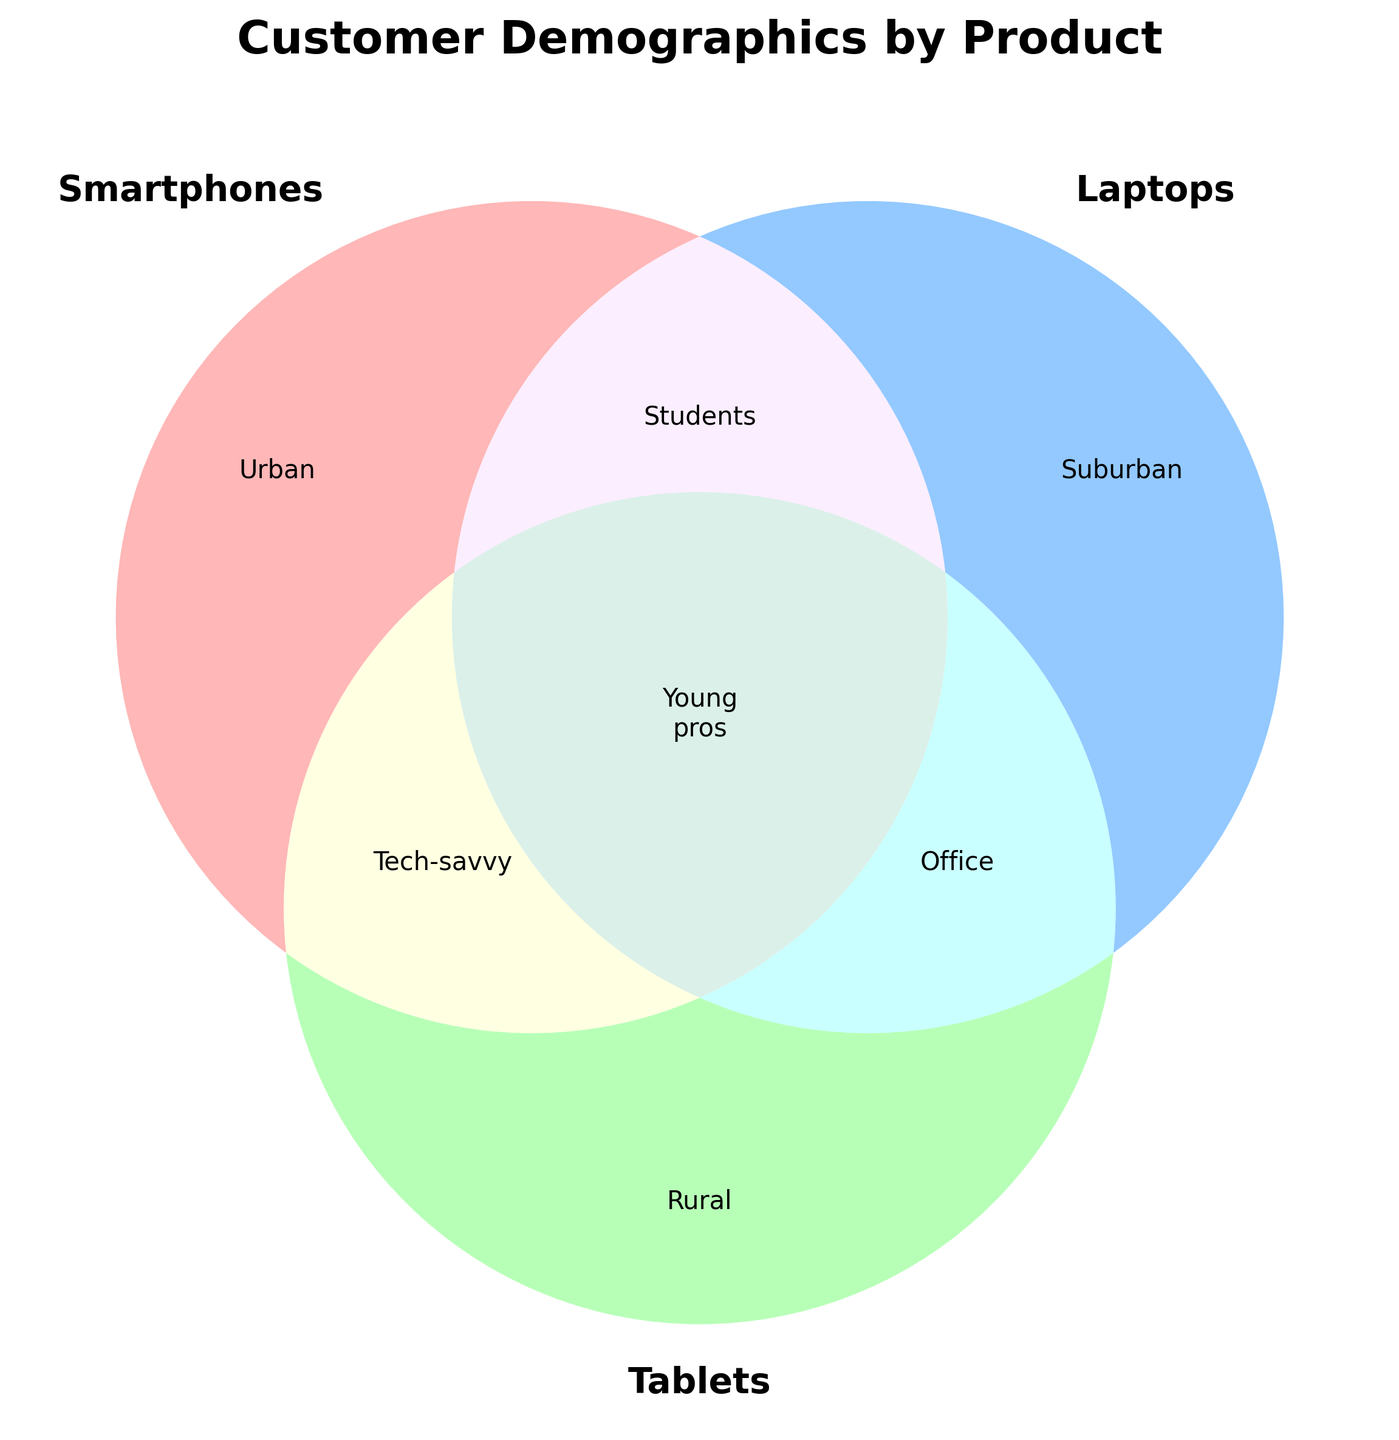Who are the main customers for Smartphones? "Smartphones" is represented in the Venn Diagram by the "Urban" label, indicating that its main customers are Urban.
Answer: Urban Who are the overlapping customers between Laptops and Tablets? The overlapping section between "Laptops" and "Tablets" is labeled "Office," indicating that Office workers are the common customers.
Answer: Office What is the main demographic for Tablets alone? The area exclusive to "Tablets" is labeled "Rural," indicating that the main demographic for Tablets alone consists of Rural buyers.
Answer: Rural What types of young professionals overlap across all three product lines? The area where all three sets overlap is labeled "Young pros," suggesting Young professionals are common customers for all three products.
Answer: Young pros Are "Tech-savvy" adults more likely exclusive to one product type? The label "Tech-savvy" appears in the overlapping part of "Smartphones" and "Tablets," indicating they are common customers of both but not exclusive to one product.
Answer: No How do Suburban families compare within the Venn Diagram? The section labeled "Laptops" exclusively represents Suburban families, indicating they are specific to Laptops, unlike other product lines.
Answer: Specific to Laptops Which group represents the overlapping customers between Smartphones and Laptops? The overlapping section between "Smartphones" and "Laptops" is labeled "Students," indicating that Students are the common customers.
Answer: Students What is the central focus of the Venn Diagram? The title 'Customer Demographics by Product' indicates that the central focus is on the demographic distribution of customers across different products.
Answer: Customer Demographics Who overlaps between Tablets and Smartphones but not Laptops? "Tech-savvy" adults overlap in the area between "Tablets" and "Smartphones" but not in "Laptops."
Answer: Tech-savvy Which product line is unanimously preferred by Educators? Educators aren’t explicitly labeled in the Venn Diagram, suggesting none of the product categories exclusively cater to them.
Answer: None 